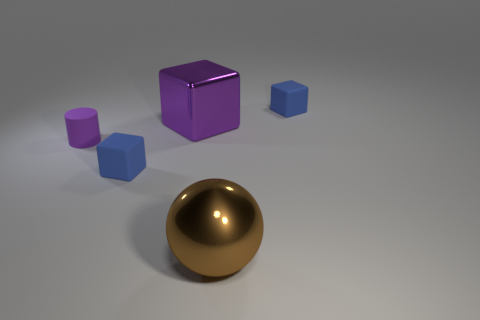Is there a large cube of the same color as the small rubber cylinder?
Your response must be concise. Yes. The brown object has what size?
Make the answer very short. Large. Is the large metallic cube the same color as the tiny rubber cylinder?
Your response must be concise. Yes. What number of things are either balls or big brown objects that are in front of the rubber cylinder?
Give a very brief answer. 1. What number of purple objects are on the left side of the blue rubber cube that is behind the matte object in front of the tiny purple thing?
Keep it short and to the point. 2. There is a large cube that is the same color as the tiny matte cylinder; what is its material?
Your answer should be very brief. Metal. How many large brown metallic balls are there?
Offer a terse response. 1. There is a shiny thing that is behind the purple matte thing; is it the same size as the large shiny ball?
Provide a short and direct response. Yes. What number of rubber things are balls or small blue objects?
Provide a short and direct response. 2. What number of big things are on the left side of the matte cube in front of the purple rubber cylinder?
Provide a short and direct response. 0. 